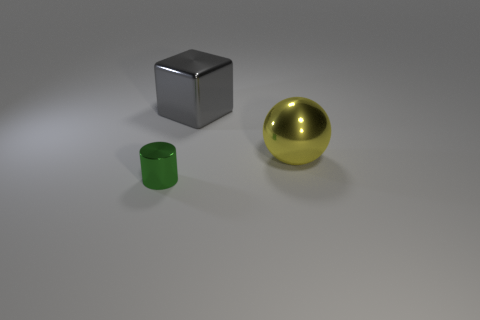If these objects were to be used in a scene, what kind of environment do you imagine them in? If these objects were placed in a scene, I could imagine them being part of a minimalist modern art exhibit due to their simple geometric shapes and clean, reflective surfaces. Alternatively, they might be found in a 3D modeling software learning tutorial, where the focus is on practicing with basic shapes and materials. 